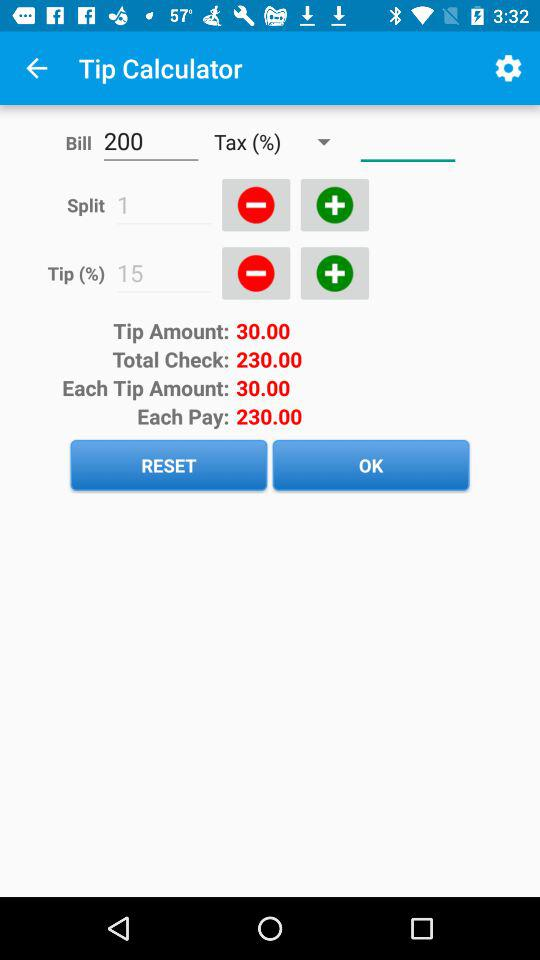What is the tip amount? The tip amount is 30.00. 